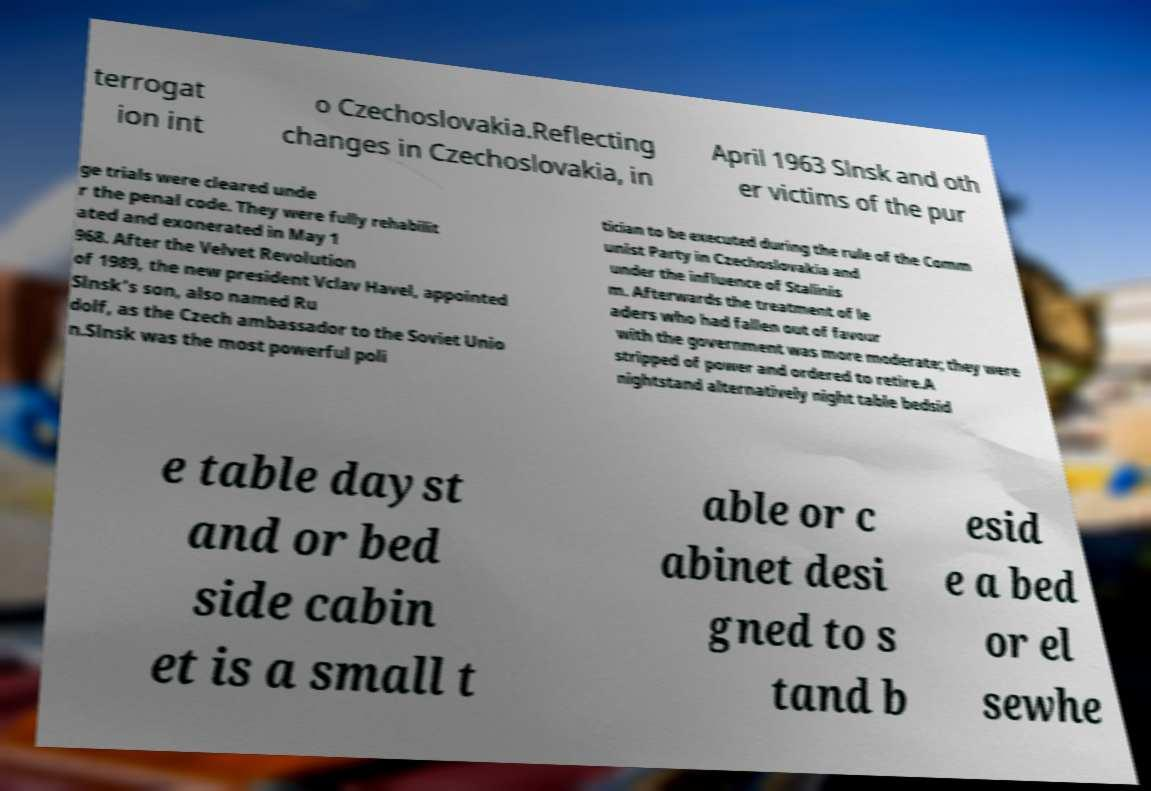Please read and relay the text visible in this image. What does it say? terrogat ion int o Czechoslovakia.Reflecting changes in Czechoslovakia, in April 1963 Slnsk and oth er victims of the pur ge trials were cleared unde r the penal code. They were fully rehabilit ated and exonerated in May 1 968. After the Velvet Revolution of 1989, the new president Vclav Havel, appointed Slnsk’s son, also named Ru dolf, as the Czech ambassador to the Soviet Unio n.Slnsk was the most powerful poli tician to be executed during the rule of the Comm unist Party in Czechoslovakia and under the influence of Stalinis m. Afterwards the treatment of le aders who had fallen out of favour with the government was more moderate; they were stripped of power and ordered to retire.A nightstand alternatively night table bedsid e table dayst and or bed side cabin et is a small t able or c abinet desi gned to s tand b esid e a bed or el sewhe 